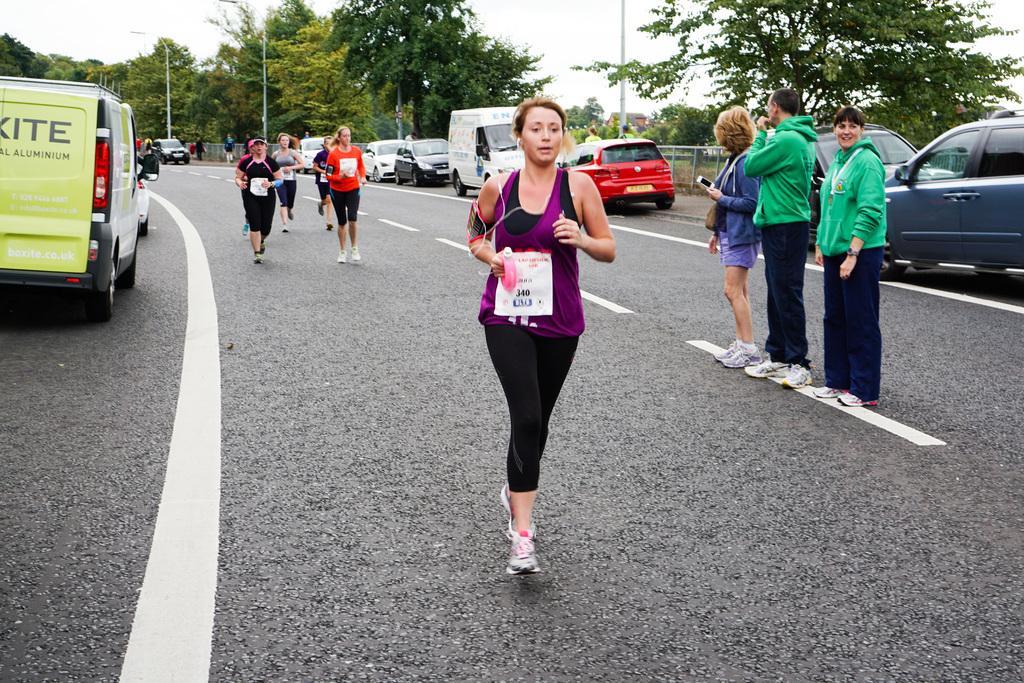In one or two sentences, can you explain what this image depicts? This image is taken outdoors. At the bottom of the image there is a road. In the background there are many trees and plant and there are a few poles with street lights. On the left side of the image two vehicles are moving on the road and a car is parked on the road. In the middle of the image a few are running on the road and a few are standing. Many cars are parked on the road. 